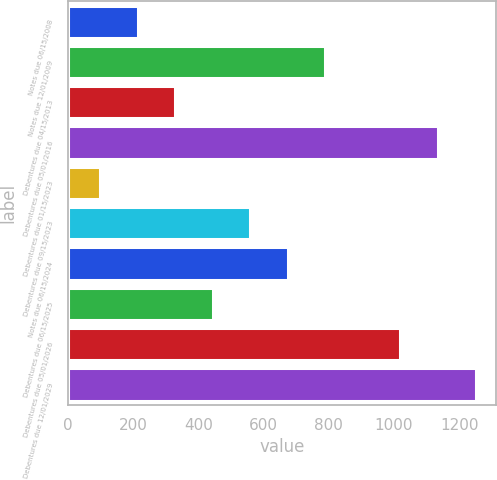<chart> <loc_0><loc_0><loc_500><loc_500><bar_chart><fcel>Notes due 06/15/2008<fcel>Notes due 12/01/2009<fcel>Debentures due 04/15/2013<fcel>Debentures due 05/01/2016<fcel>Debentures due 01/15/2023<fcel>Debentures due 09/15/2023<fcel>Notes due 06/15/2024<fcel>Debentures due 06/15/2025<fcel>Debentures due 05/01/2026<fcel>Debentures due 12/01/2029<nl><fcel>215<fcel>790<fcel>330<fcel>1135<fcel>100<fcel>560<fcel>675<fcel>445<fcel>1020<fcel>1250<nl></chart> 